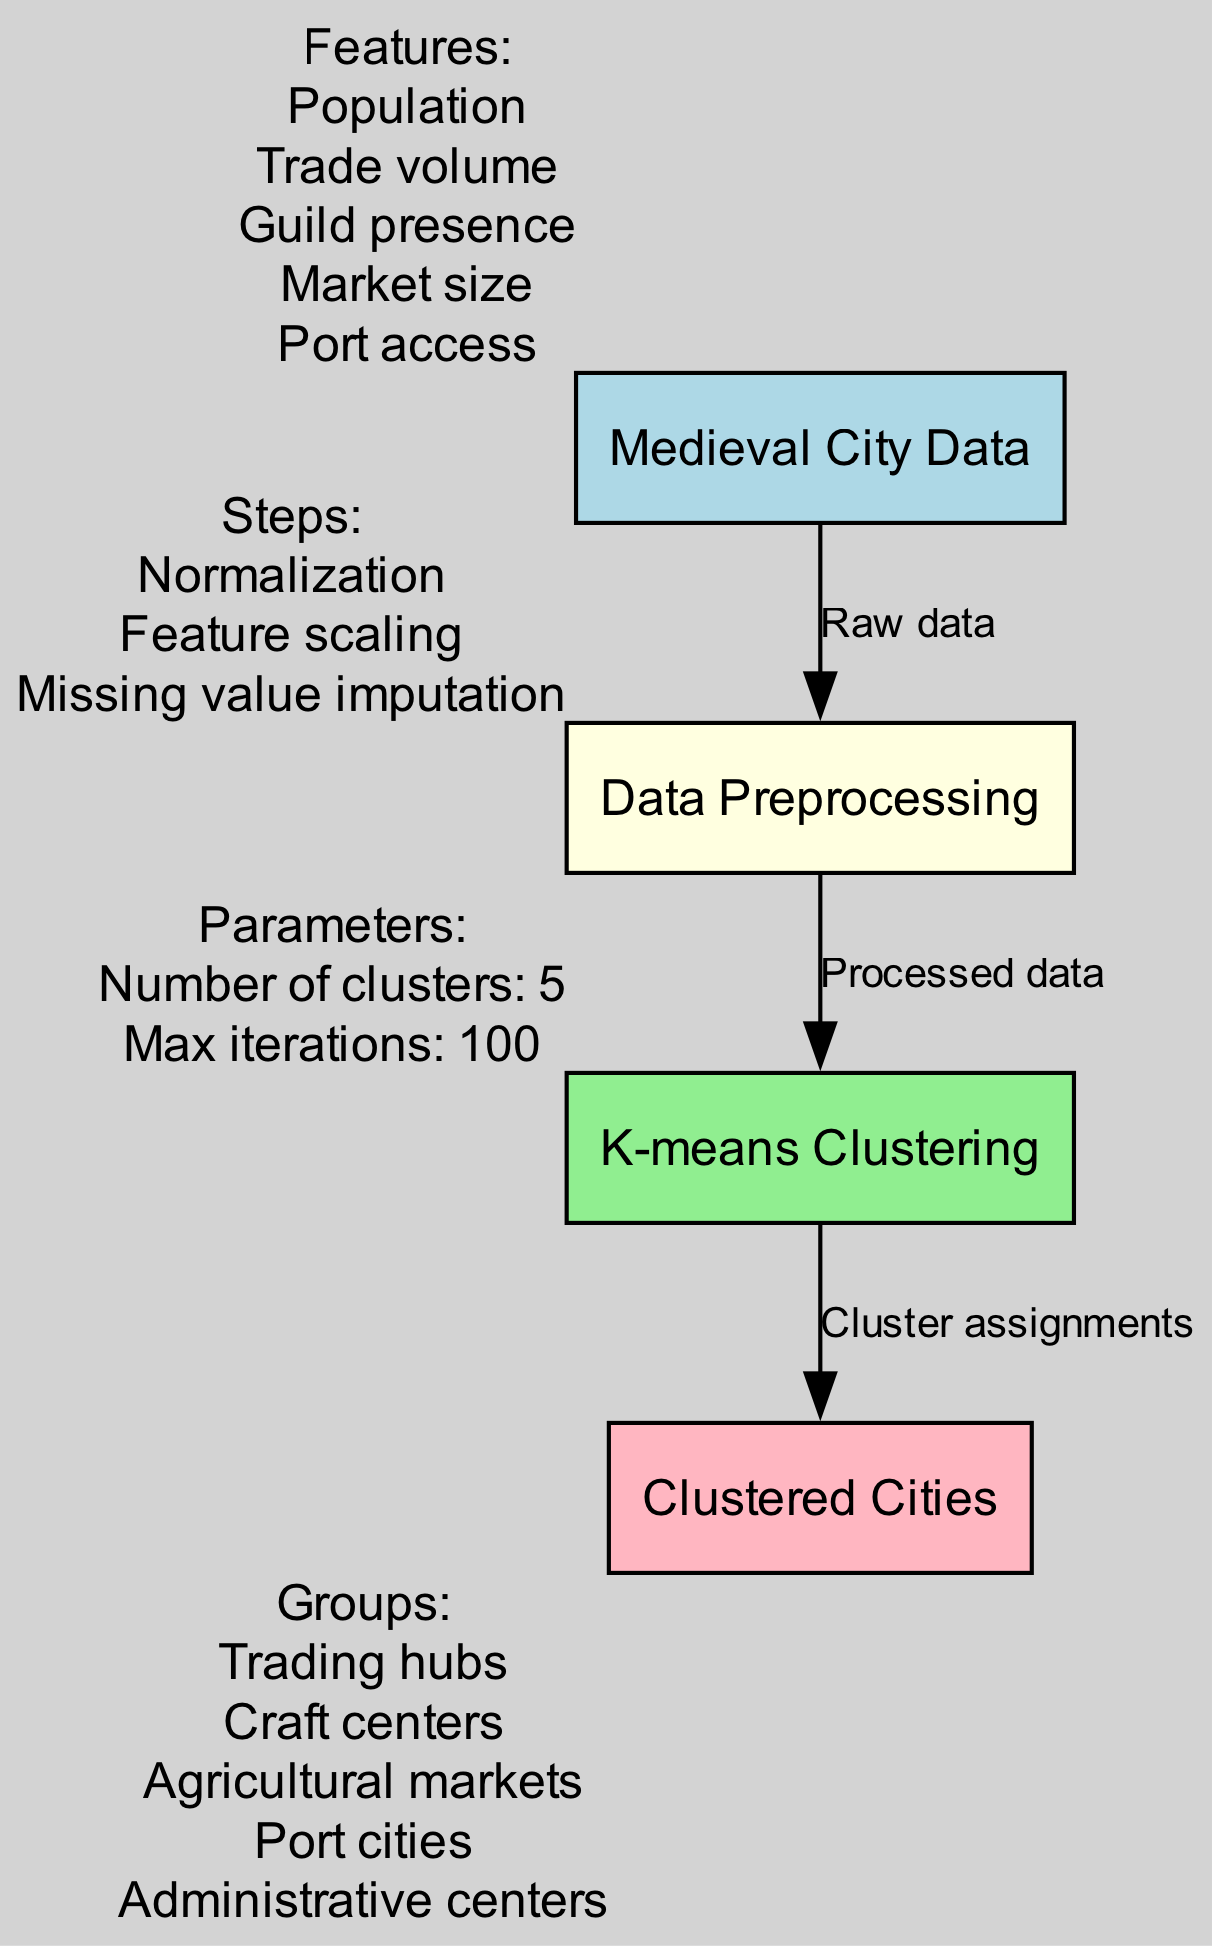What are the features of the medieval city data? The diagram lists five features under the "Medieval City Data" node: Population, Trade volume, Guild presence, Market size, and Port access.
Answer: Population, Trade volume, Guild presence, Market size, Port access What preprocessing steps are included? The "Data Preprocessing" node outlines three steps: Normalization, Feature scaling, and Missing value imputation.
Answer: Normalization, Feature scaling, Missing value imputation How many clusters are used in the K-means clustering? The "K-means Clustering" node specifies that the number of clusters is set to 5.
Answer: 5 What is the final output of the clustering analysis? The "Clustered Cities" node categorizes the cities into five groups: Trading hubs, Craft centers, Agricultural markets, Port cities, and Administrative centers.
Answer: Trading hubs, Craft centers, Agricultural markets, Port cities, Administrative centers What is the relationship between the preprocessing and clustering nodes? The edge labeled "Processed data" connects the "Data Preprocessing" node to the "K-means Clustering" node, indicating that the data is processed before clustering.
Answer: Processed data Which nodes represent input and output in the diagram? The "Medieval City Data" node represents input, while the "Clustered Cities" node represents output in the diagram.
Answer: Medieval City Data, Clustered Cities How many edges are present in the diagram? The diagram contains three edges that connect the nodes, indicating the flow of data through the analysis process.
Answer: 3 What type of clustering is performed in the diagram? The diagram specifies that K-means clustering is the type performed to categorize the medieval cities based on their economic characteristics.
Answer: K-means clustering Which group in the output features cities with market access? Among the output groups, "Port cities" most directly features cities with market access due to their geographical advantage for trade.
Answer: Port cities 